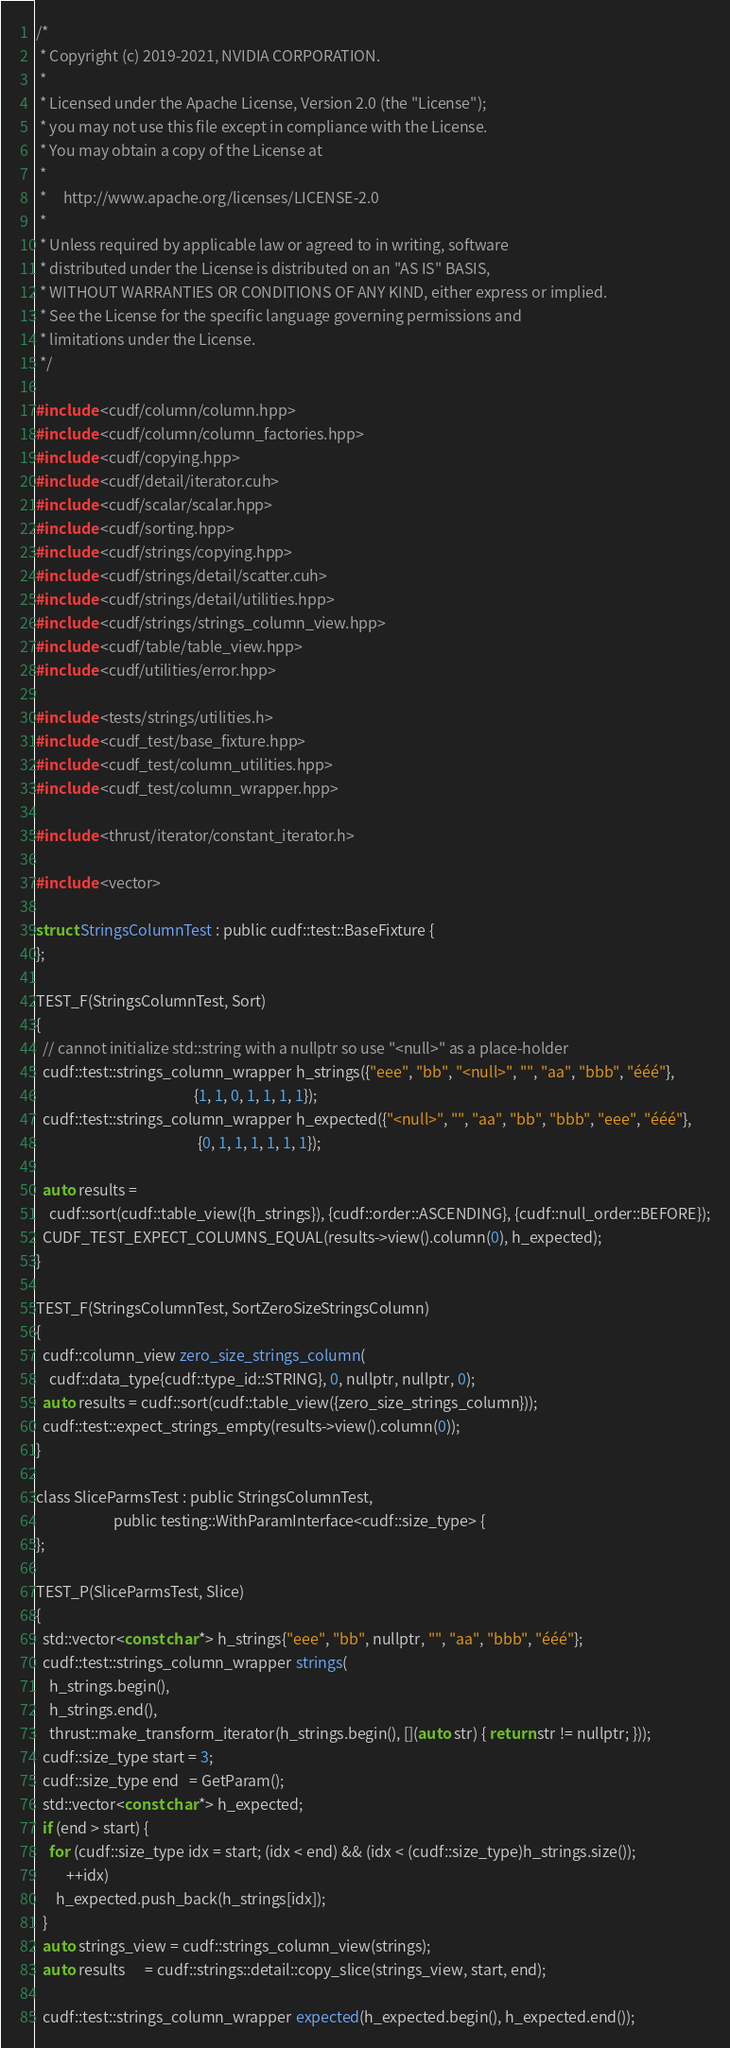<code> <loc_0><loc_0><loc_500><loc_500><_Cuda_>/*
 * Copyright (c) 2019-2021, NVIDIA CORPORATION.
 *
 * Licensed under the Apache License, Version 2.0 (the "License");
 * you may not use this file except in compliance with the License.
 * You may obtain a copy of the License at
 *
 *     http://www.apache.org/licenses/LICENSE-2.0
 *
 * Unless required by applicable law or agreed to in writing, software
 * distributed under the License is distributed on an "AS IS" BASIS,
 * WITHOUT WARRANTIES OR CONDITIONS OF ANY KIND, either express or implied.
 * See the License for the specific language governing permissions and
 * limitations under the License.
 */

#include <cudf/column/column.hpp>
#include <cudf/column/column_factories.hpp>
#include <cudf/copying.hpp>
#include <cudf/detail/iterator.cuh>
#include <cudf/scalar/scalar.hpp>
#include <cudf/sorting.hpp>
#include <cudf/strings/copying.hpp>
#include <cudf/strings/detail/scatter.cuh>
#include <cudf/strings/detail/utilities.hpp>
#include <cudf/strings/strings_column_view.hpp>
#include <cudf/table/table_view.hpp>
#include <cudf/utilities/error.hpp>

#include <tests/strings/utilities.h>
#include <cudf_test/base_fixture.hpp>
#include <cudf_test/column_utilities.hpp>
#include <cudf_test/column_wrapper.hpp>

#include <thrust/iterator/constant_iterator.h>

#include <vector>

struct StringsColumnTest : public cudf::test::BaseFixture {
};

TEST_F(StringsColumnTest, Sort)
{
  // cannot initialize std::string with a nullptr so use "<null>" as a place-holder
  cudf::test::strings_column_wrapper h_strings({"eee", "bb", "<null>", "", "aa", "bbb", "ééé"},
                                               {1, 1, 0, 1, 1, 1, 1});
  cudf::test::strings_column_wrapper h_expected({"<null>", "", "aa", "bb", "bbb", "eee", "ééé"},
                                                {0, 1, 1, 1, 1, 1, 1});

  auto results =
    cudf::sort(cudf::table_view({h_strings}), {cudf::order::ASCENDING}, {cudf::null_order::BEFORE});
  CUDF_TEST_EXPECT_COLUMNS_EQUAL(results->view().column(0), h_expected);
}

TEST_F(StringsColumnTest, SortZeroSizeStringsColumn)
{
  cudf::column_view zero_size_strings_column(
    cudf::data_type{cudf::type_id::STRING}, 0, nullptr, nullptr, 0);
  auto results = cudf::sort(cudf::table_view({zero_size_strings_column}));
  cudf::test::expect_strings_empty(results->view().column(0));
}

class SliceParmsTest : public StringsColumnTest,
                       public testing::WithParamInterface<cudf::size_type> {
};

TEST_P(SliceParmsTest, Slice)
{
  std::vector<const char*> h_strings{"eee", "bb", nullptr, "", "aa", "bbb", "ééé"};
  cudf::test::strings_column_wrapper strings(
    h_strings.begin(),
    h_strings.end(),
    thrust::make_transform_iterator(h_strings.begin(), [](auto str) { return str != nullptr; }));
  cudf::size_type start = 3;
  cudf::size_type end   = GetParam();
  std::vector<const char*> h_expected;
  if (end > start) {
    for (cudf::size_type idx = start; (idx < end) && (idx < (cudf::size_type)h_strings.size());
         ++idx)
      h_expected.push_back(h_strings[idx]);
  }
  auto strings_view = cudf::strings_column_view(strings);
  auto results      = cudf::strings::detail::copy_slice(strings_view, start, end);

  cudf::test::strings_column_wrapper expected(h_expected.begin(), h_expected.end());</code> 